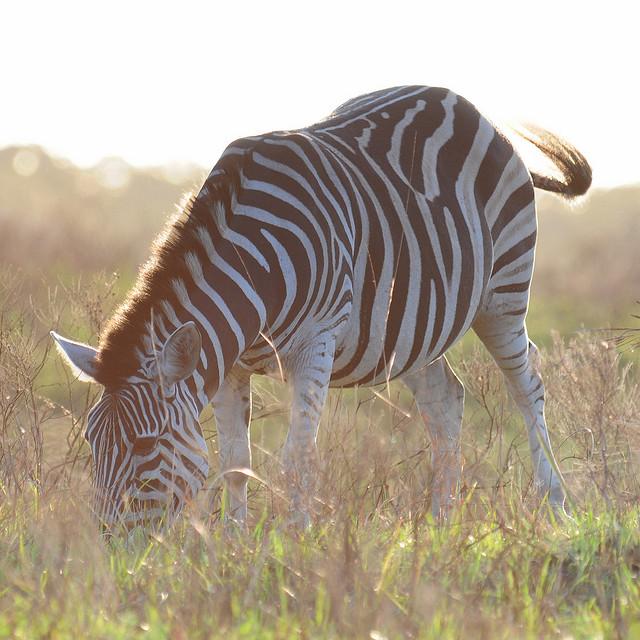Is the zebra eating?
Write a very short answer. Yes. Is the light from the sun?
Quick response, please. Yes. Is this zebra looking for its colt?
Quick response, please. No. 